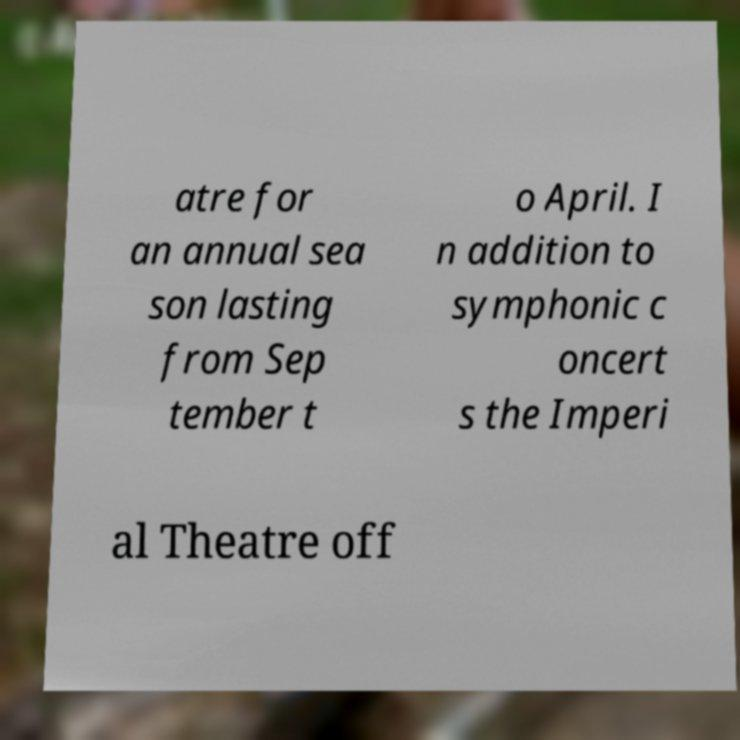Can you read and provide the text displayed in the image?This photo seems to have some interesting text. Can you extract and type it out for me? atre for an annual sea son lasting from Sep tember t o April. I n addition to symphonic c oncert s the Imperi al Theatre off 